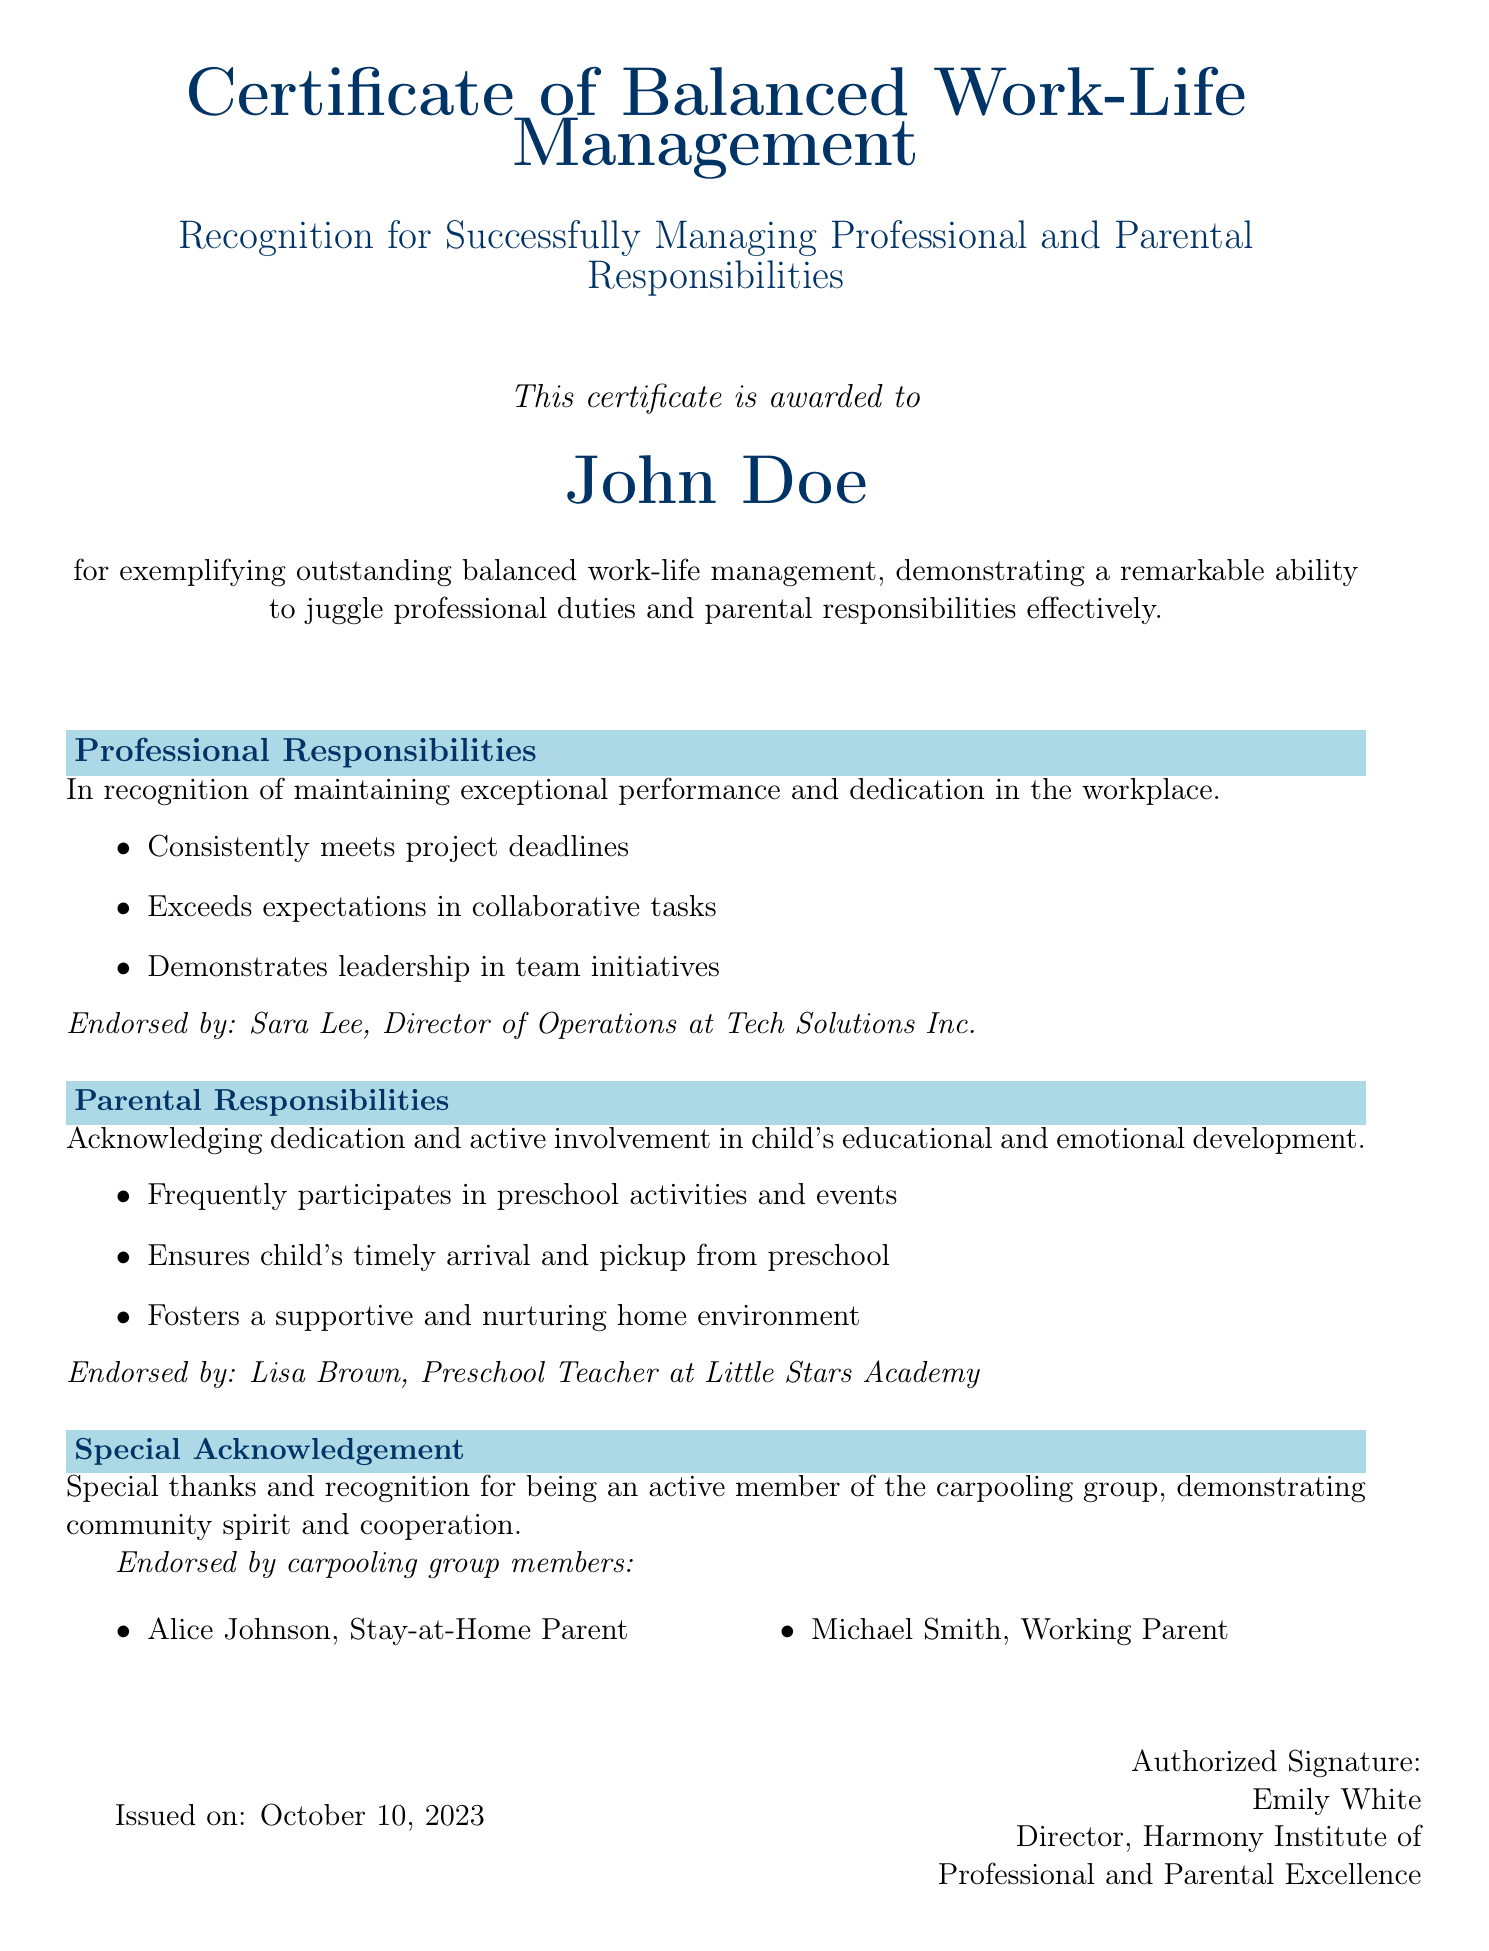What is the title of the certificate? The title of the certificate is specified at the top of the document, highlighting the achievement.
Answer: Certificate of Balanced Work-Life Management Who is the certificate awarded to? The name of the individual receiving the certificate is mentioned prominently within the document.
Answer: John Doe What is the date of issuance? The date when the certificate was issued can be found towards the end of the document.
Answer: October 10, 2023 Who endorsed the professional responsibilities section? The endorsement for the professional responsibilities section is provided by a specific individual mentioned in the document.
Answer: Sara Lee What are two responsibilities highlighted under parental responsibilities? The document lists three responsibilities related to parental involvement; two of them are specified for clarity.
Answer: Participates in preschool activities, Ensures child's timely arrival What special recognition is mentioned in the document? This refers to a specific acknowledgment in the certificate pertaining to a collective activity within the community.
Answer: Active member of the carpooling group What is the name of the issuing organization? The name of the organization that issued the certificate is stated at the bottom of the document.
Answer: Harmony Institute of Professional and Parental Excellence Who signed the certificate? The document includes information about the individual who authorized the signing of the certificate.
Answer: Emily White 